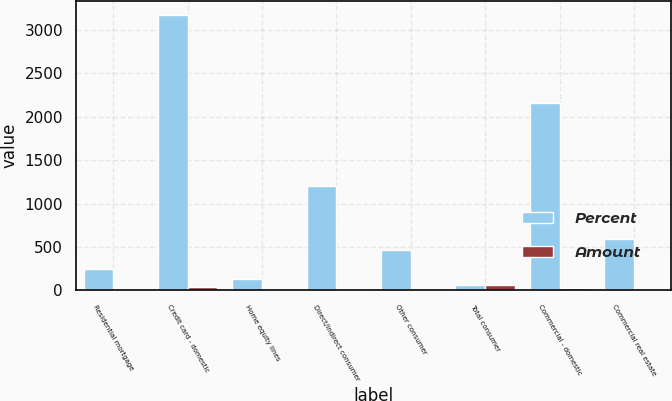Convert chart. <chart><loc_0><loc_0><loc_500><loc_500><stacked_bar_chart><ecel><fcel>Residential mortgage<fcel>Credit card - domestic<fcel>Home equity lines<fcel>Direct/Indirect consumer<fcel>Other consumer<fcel>Total consumer<fcel>Commercial - domestic<fcel>Commercial real estate<nl><fcel>Percent<fcel>248<fcel>3176<fcel>133<fcel>1200<fcel>467<fcel>61.7<fcel>2162<fcel>588<nl><fcel>Amount<fcel>2.8<fcel>35.2<fcel>1.5<fcel>13.3<fcel>5.2<fcel>61.7<fcel>24<fcel>6.5<nl></chart> 